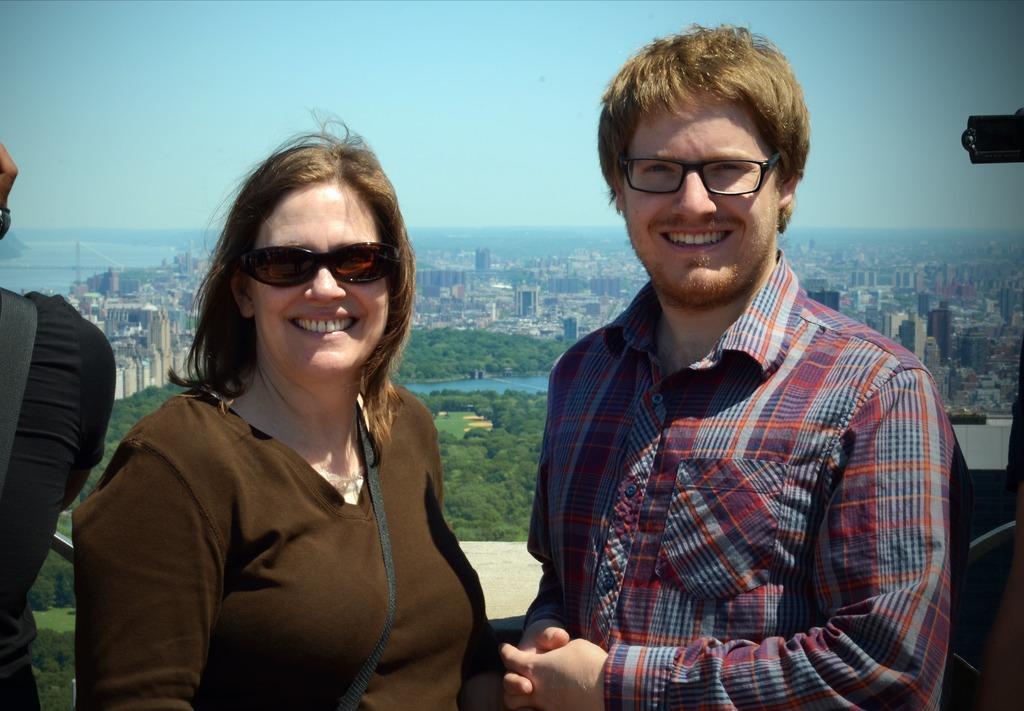Can you describe this image briefly? In this picture we can see two persons mainly man and woman standing at some place and both of them are laughing and both wore spectacles and man wore shirt, woman wore T Shirt and the background we can see so many buildings, sky, trees, water. 